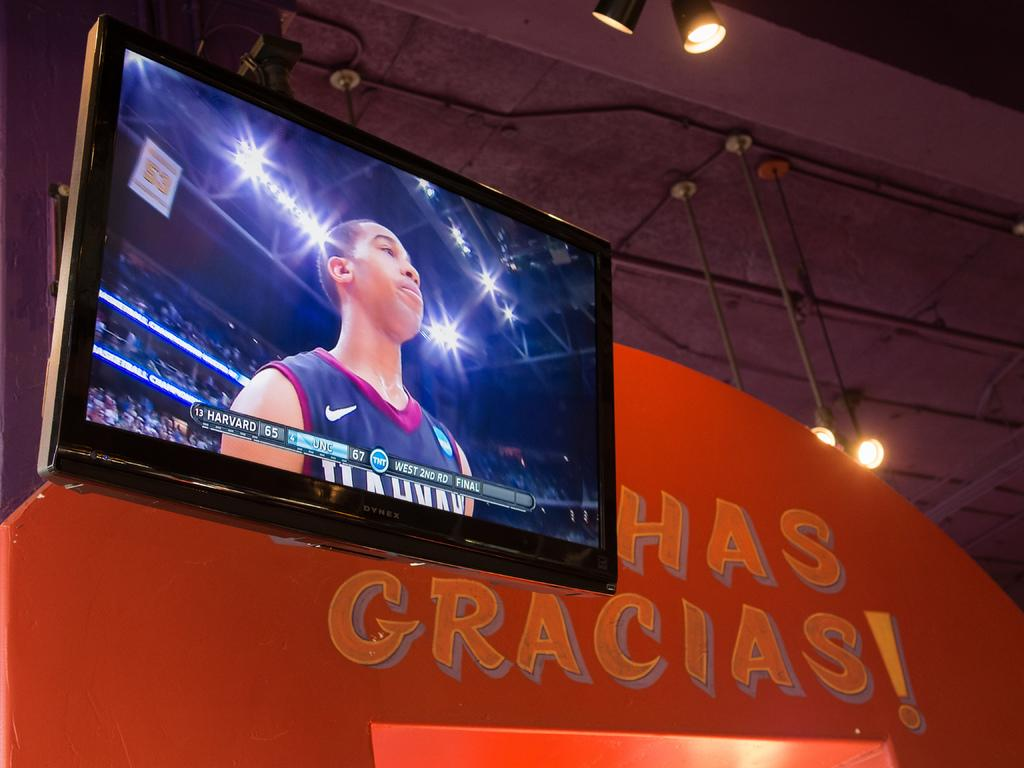<image>
Create a compact narrative representing the image presented. A television shows a basketball game in front of a sign that says Muchas Gracias. 